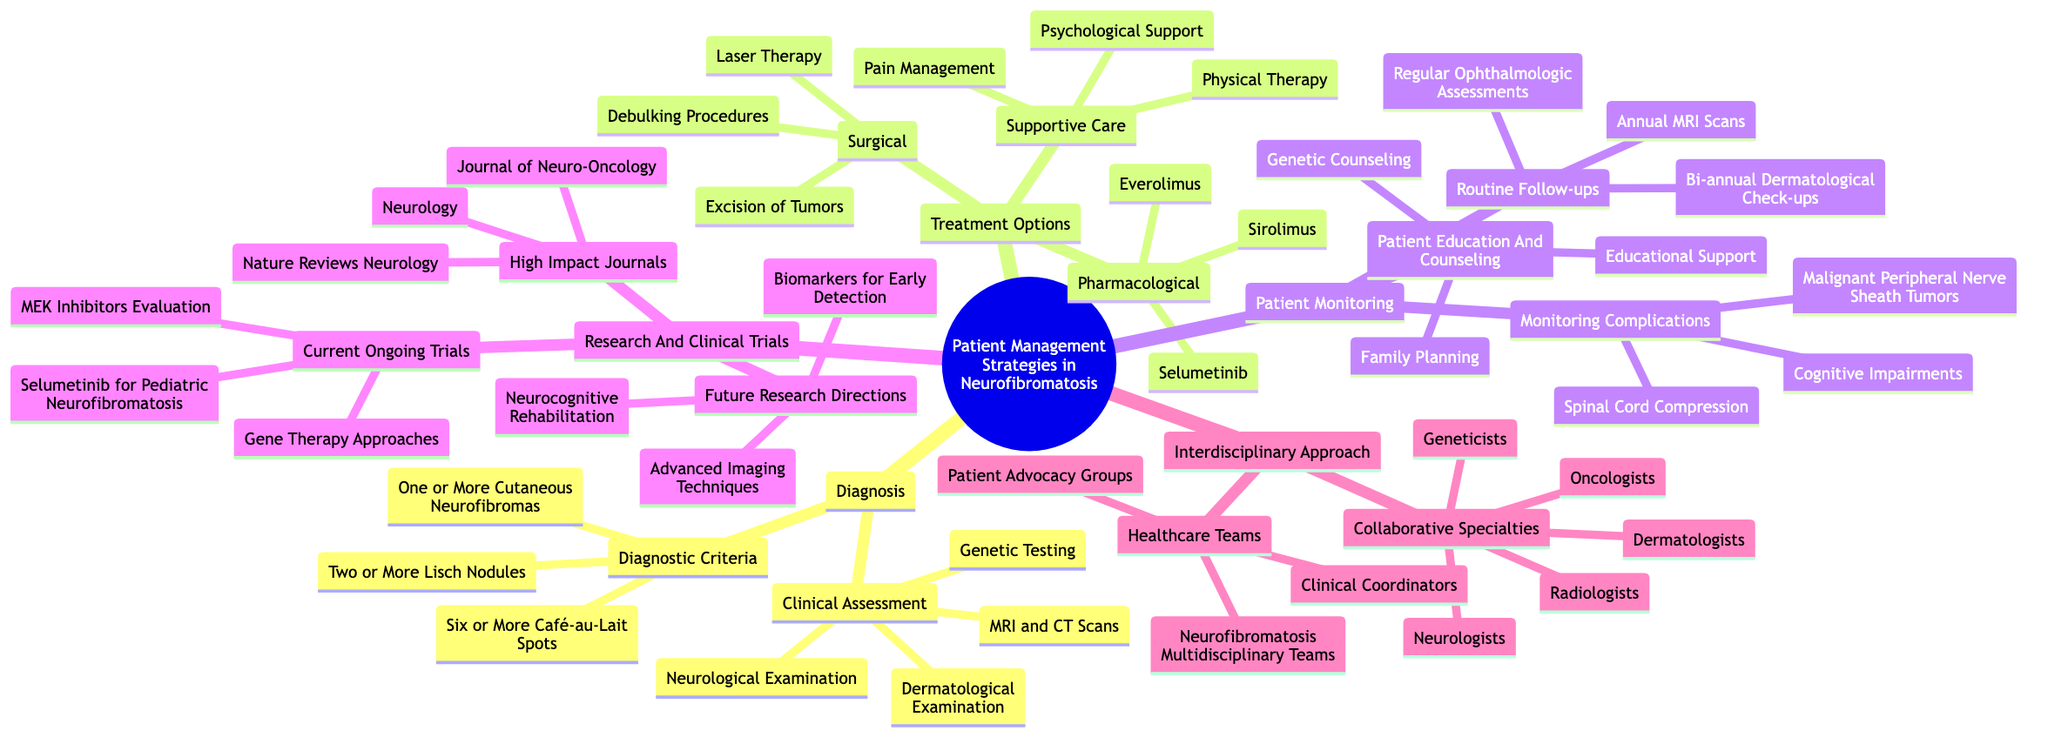What are the pharmacological treatment options listed in the diagram? The diagram lists three pharmacological treatment options under Treatment Options: Selumetinib, Sirolimus, and Everolimus.
Answer: Selumetinib, Sirolimus, Everolimus How many healthcare teams are identified in the Interdisciplinary Approach section? The diagram shows three types of healthcare teams listed under the Interdisciplinary Approach, which are Neurofibromatosis Multidisciplinary Teams, Patient Advocacy Groups, and Clinical Coordinators.
Answer: 3 What is one of the diagnostic criteria for Neurofibromatosis? The diagram provides three diagnostic criteria in the Diagnostic Criteria section; one of them is "Six or More Café-au-Lait Spots."
Answer: Six or More Café-au-Lait Spots What are the two categories of patient monitoring mentioned? The Patient Monitoring section indicates three components, two of which are Routine Follow-ups and Monitoring Complications.
Answer: Routine Follow-ups, Monitoring Complications Which type of interdisciplinary specialists is NOT listed in the Collaborative Specialties? The Collaborative Specialties section lists Neurologists, Dermatologists, Oncologists, Radiologists, and Geneticists, so "Pediatricians" is not mentioned.
Answer: Pediatricians Name one area of future research direction noted in the Research And Clinical Trials section. The Future Research Directions section includes three areas, one of which is "Biomarkers for Early Detection."
Answer: Biomarkers for Early Detection How often are routine follow-ups recommended for patient management? The Routine Follow-ups section specifies "Bi-annual Dermatological Check-ups," indicating that follow-ups are recommended twice a year.
Answer: Bi-annual What type of support is included in the Supportive Care options? Among the listed Supportive Care options, "Psychological Support" is highlighted as one of the areas to assist patients.
Answer: Psychological Support What is the focus of the current ongoing trial related to Selumetinib? The Research And Clinical Trials section specifies that the ongoing trial focuses on "Selumetinib for Pediatric Neurofibromatosis."
Answer: Selumetinib for Pediatric Neurofibromatosis 